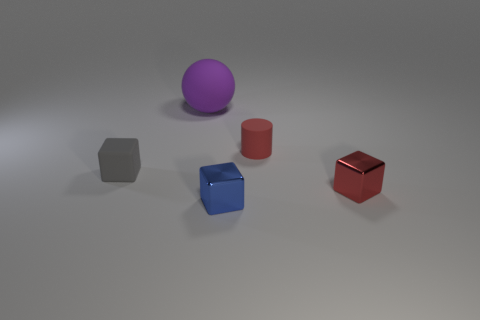Do the large object and the tiny rubber thing to the left of the rubber sphere have the same shape?
Keep it short and to the point. No. What number of other things are the same shape as the purple rubber thing?
Make the answer very short. 0. How many things are either gray matte things or large cyan cylinders?
Offer a very short reply. 1. Is the rubber cylinder the same color as the rubber sphere?
Your answer should be compact. No. Are there any other things that are the same size as the purple sphere?
Give a very brief answer. No. There is a tiny red thing that is behind the small rubber thing to the left of the big purple matte sphere; what shape is it?
Provide a succinct answer. Cylinder. Is the number of rubber blocks less than the number of tiny yellow matte blocks?
Offer a terse response. No. There is a matte thing that is both in front of the purple sphere and on the right side of the tiny gray rubber cube; what is its size?
Provide a short and direct response. Small. Is the matte cylinder the same size as the purple sphere?
Your answer should be compact. No. There is a small rubber object that is to the right of the small gray matte block; is its color the same as the small matte cube?
Keep it short and to the point. No. 